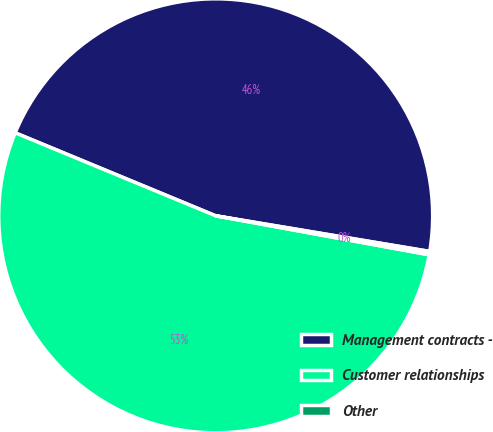<chart> <loc_0><loc_0><loc_500><loc_500><pie_chart><fcel>Management contracts -<fcel>Customer relationships<fcel>Other<nl><fcel>46.38%<fcel>53.37%<fcel>0.25%<nl></chart> 